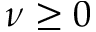<formula> <loc_0><loc_0><loc_500><loc_500>\nu \geq 0</formula> 